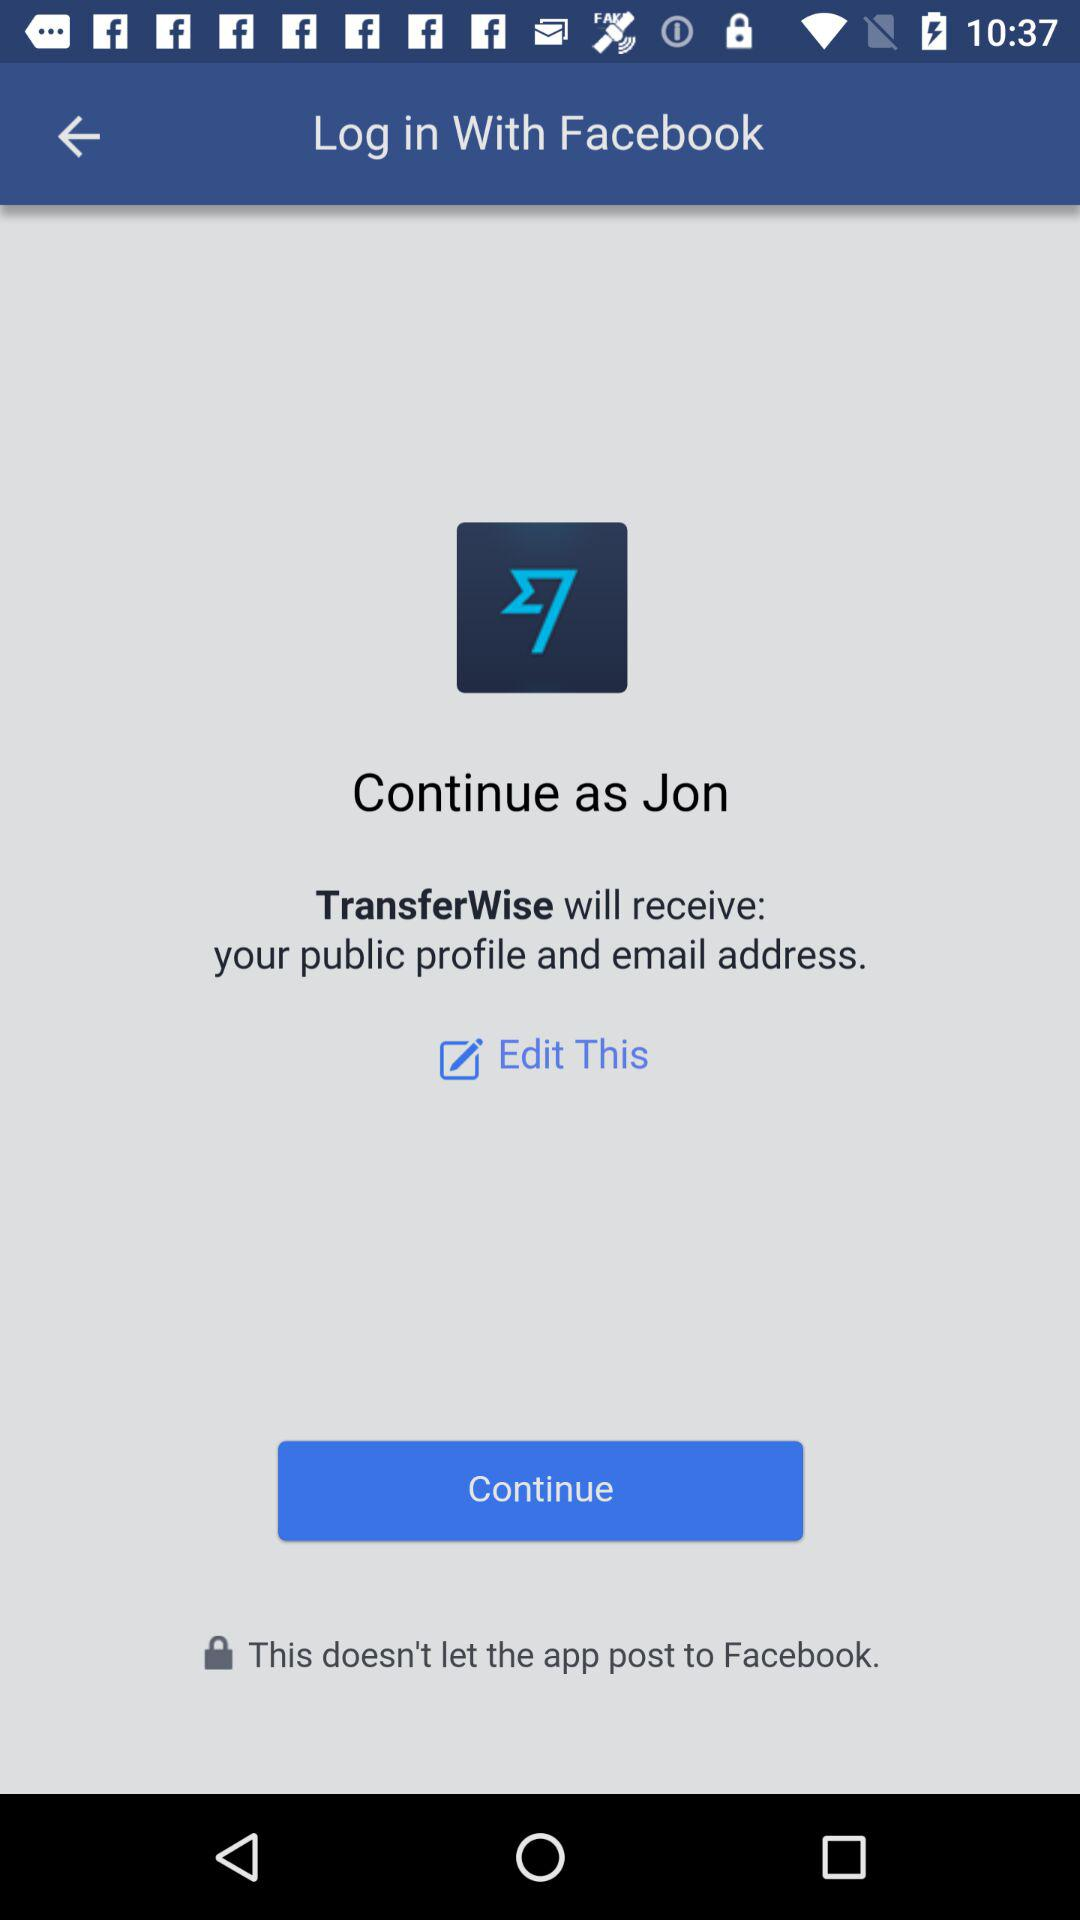What is the shown login name? The login name is Jon. 